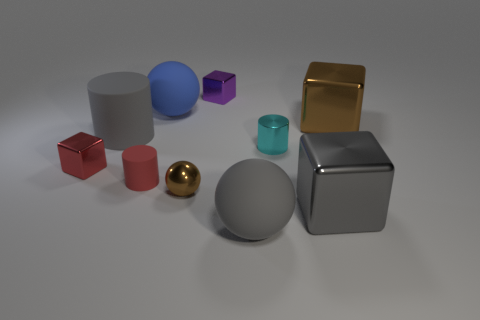Subtract all matte cylinders. How many cylinders are left? 1 Subtract all gray blocks. How many blocks are left? 3 Subtract all cylinders. How many objects are left? 7 Subtract 1 blocks. How many blocks are left? 3 Subtract 1 gray blocks. How many objects are left? 9 Subtract all yellow cubes. Subtract all purple cylinders. How many cubes are left? 4 Subtract all yellow cylinders. How many blue balls are left? 1 Subtract all big gray rubber balls. Subtract all cylinders. How many objects are left? 6 Add 1 rubber cylinders. How many rubber cylinders are left? 3 Add 8 big blue cylinders. How many big blue cylinders exist? 8 